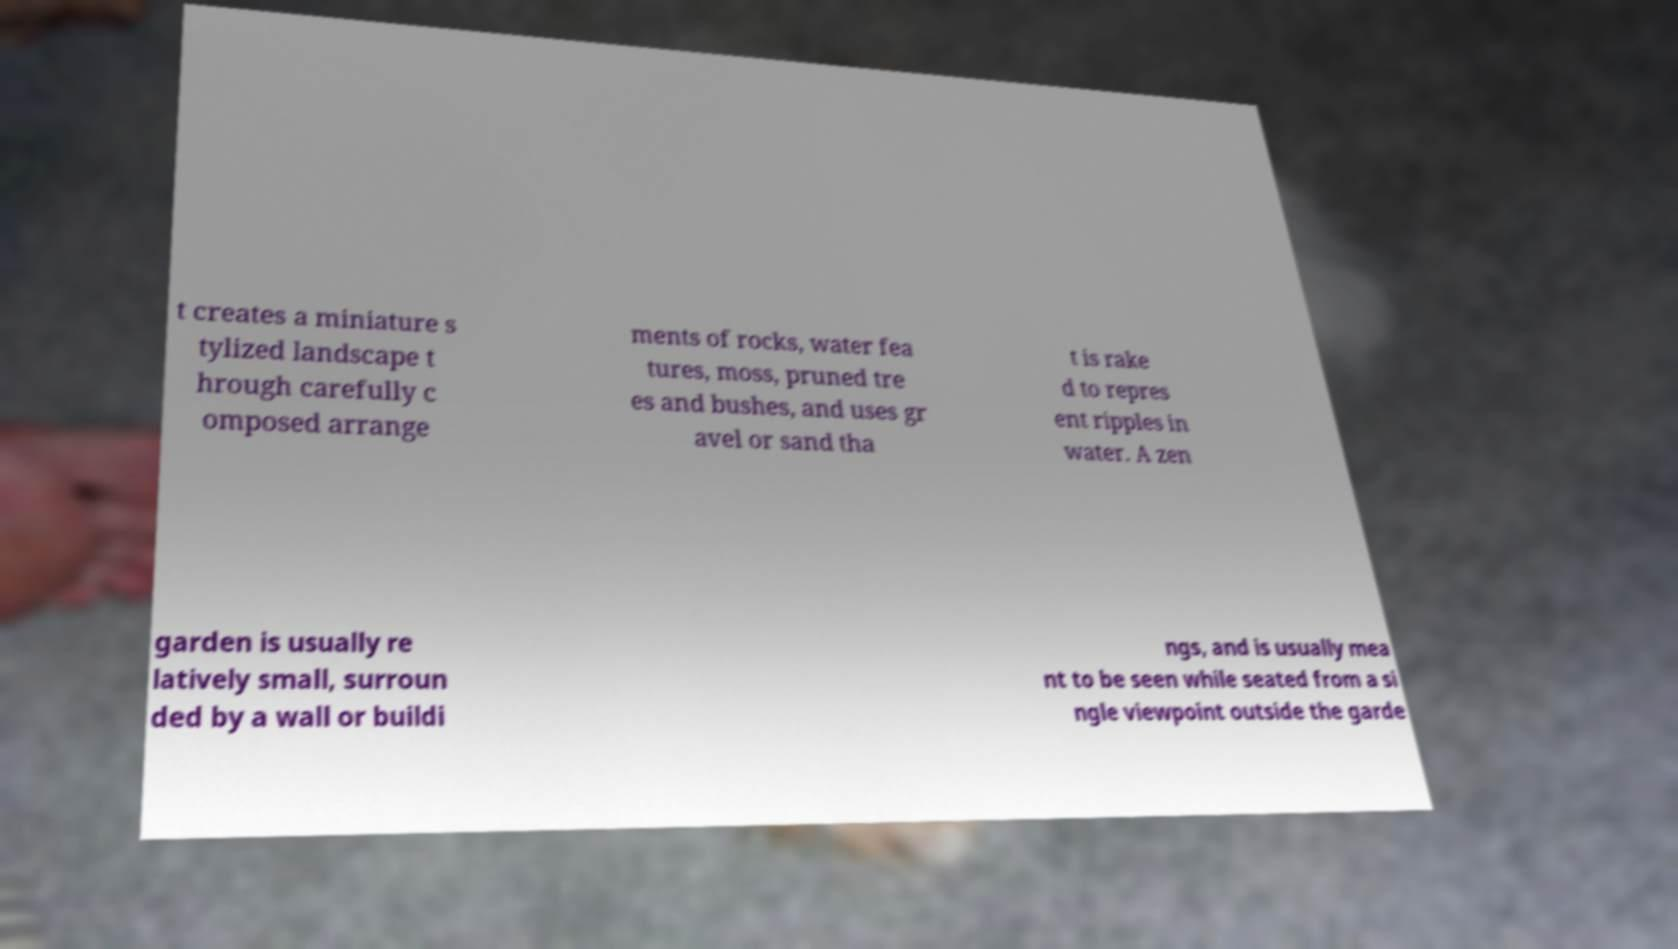Can you read and provide the text displayed in the image?This photo seems to have some interesting text. Can you extract and type it out for me? t creates a miniature s tylized landscape t hrough carefully c omposed arrange ments of rocks, water fea tures, moss, pruned tre es and bushes, and uses gr avel or sand tha t is rake d to repres ent ripples in water. A zen garden is usually re latively small, surroun ded by a wall or buildi ngs, and is usually mea nt to be seen while seated from a si ngle viewpoint outside the garde 